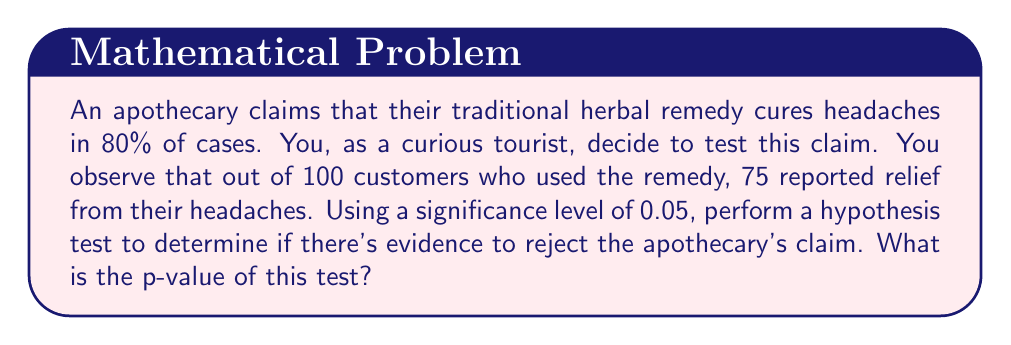Show me your answer to this math problem. Let's approach this step-by-step:

1) First, we need to set up our hypotheses:
   $H_0: p = 0.80$ (null hypothesis: the cure rate is 80%)
   $H_a: p < 0.80$ (alternative hypothesis: the cure rate is less than 80%)

2) We're dealing with a binomial distribution. For large samples (n ≥ 30), we can use the normal approximation to the binomial.

3) Calculate the test statistic:
   $z = \frac{\hat{p} - p_0}{\sqrt{\frac{p_0(1-p_0)}{n}}}$

   Where:
   $\hat{p} = \frac{75}{100} = 0.75$ (sample proportion)
   $p_0 = 0.80$ (claimed proportion)
   $n = 100$ (sample size)

4) Plugging in the values:
   $z = \frac{0.75 - 0.80}{\sqrt{\frac{0.80(1-0.80)}{100}}}$
   $= \frac{-0.05}{\sqrt{\frac{0.16}{100}}}$
   $= \frac{-0.05}{0.04}$
   $= -1.25$

5) To find the p-value, we need to calculate the probability of observing a z-score of -1.25 or less (because it's a left-tailed test).

6) Using a standard normal distribution table or calculator:
   $P(Z \leq -1.25) \approx 0.1056$

Therefore, the p-value is approximately 0.1056.
Answer: 0.1056 